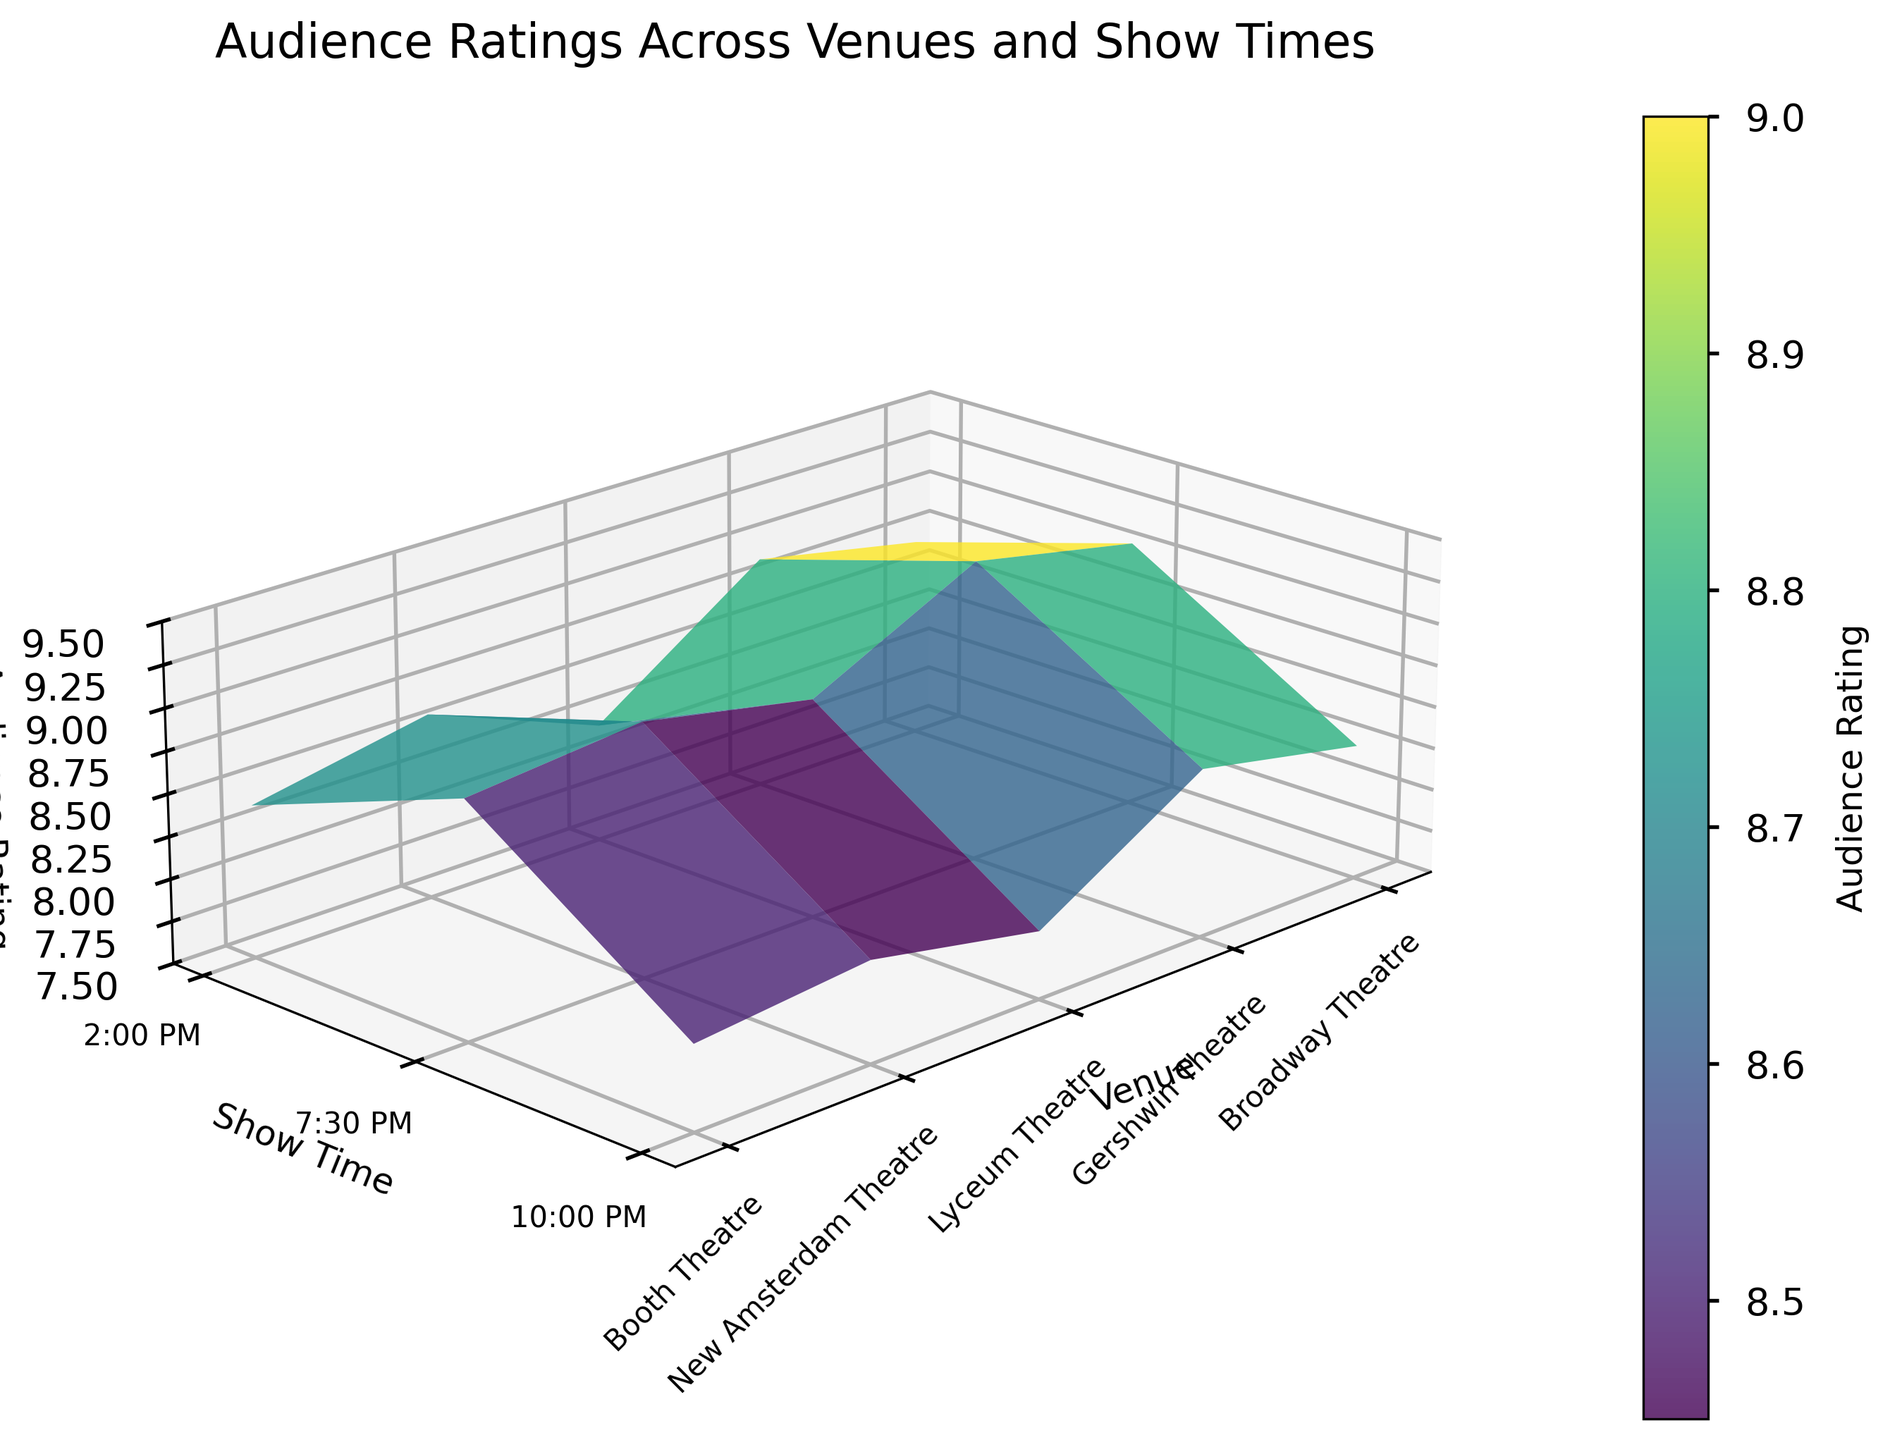what is the z-label on the figure? The z-axis label is labeled in the plot. It shows that the z-axis represents "Audience Rating".
Answer: Audience Rating what's the highest audience rating among all venues and show times? By looking at the surface plot, identify the peak value on the z-axis, which indicates the highest audience rating point. This appears to be at 9.3.
Answer: 9.3 which venue has the highest average audience rating? The Gershwin Theatre has the highest points looking from the figure. Calculating the average for each venue (Broadway Theatre: 8.7+9.1+8.3=26.1/3=8.7, Gershwin Theatre: 8.9+9.3+8.5=26.7/3=8.9, Lyceum Theatre: 8.2+8.8+7.9=24.9/3=8.3, New Amsterdam Theatre: 8.6+9.0+8.1=25.7/3=8.6, Booth Theatre: 8.4+8.9+8.0=25.3/3=8.4), we find Gershwin Theatre has the highest average at 8.9.
Answer: Gershwin Theatre What's the audience rating at 7:30 PM at the venue with the lowest average rating? First, identify the venue with the lowest average rating from the surface plot, which is the Lyceum Theatre with an average of 8.3. Then, check the audience rating at 7:30 PM for that venue.
Answer: 8.8 which show time generally has the lowest audience rating across all venues? Examine the surface plot for the z-axis values corresponding to each show time. Average the z-values visually for 2:00 PM, 7:30 PM, and 10:00 PM. 10:00 PM has the generally lower ratings overall points.
Answer: 10:00 PM what’s the difference in audience rating between Lyceum Theatre and New Amsterdam Theatre at 2:00 PM? Find the audience rating at 2:00 PM for Lyceum Theatre (8.2) and New Amsterdam Theatre (8.6) and calculate the difference (8.6 - 8.2).
Answer: 0.4 which show time has the highest audience rating at Broadway Theatre? Look for the highest point on the z-axis at different show times for Broadway Theatre. The highest rating is at 7:30 PM.
Answer: 7:30 PM how does the audience rating at 2:00 PM at Booth Theatre compare to the rating at 10:00 PM at Gershwin Theatre? Compare the z-axis values directly. Booth Theatre at 2:00 PM has a rating of 8.4, while Gershwin Theatre at 10:00 PM has a rating of 8.5.
Answer: Gershwin Theatre has a slightly higher rating at 10:00 PM 